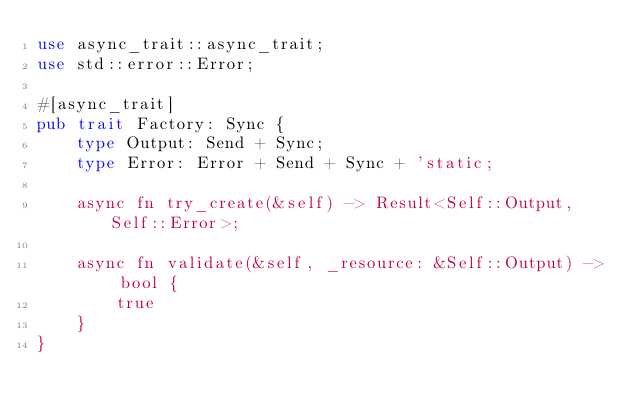<code> <loc_0><loc_0><loc_500><loc_500><_Rust_>use async_trait::async_trait;
use std::error::Error;

#[async_trait]
pub trait Factory: Sync {
    type Output: Send + Sync;
    type Error: Error + Send + Sync + 'static;

    async fn try_create(&self) -> Result<Self::Output, Self::Error>;

    async fn validate(&self, _resource: &Self::Output) -> bool {
        true
    }
}
</code> 